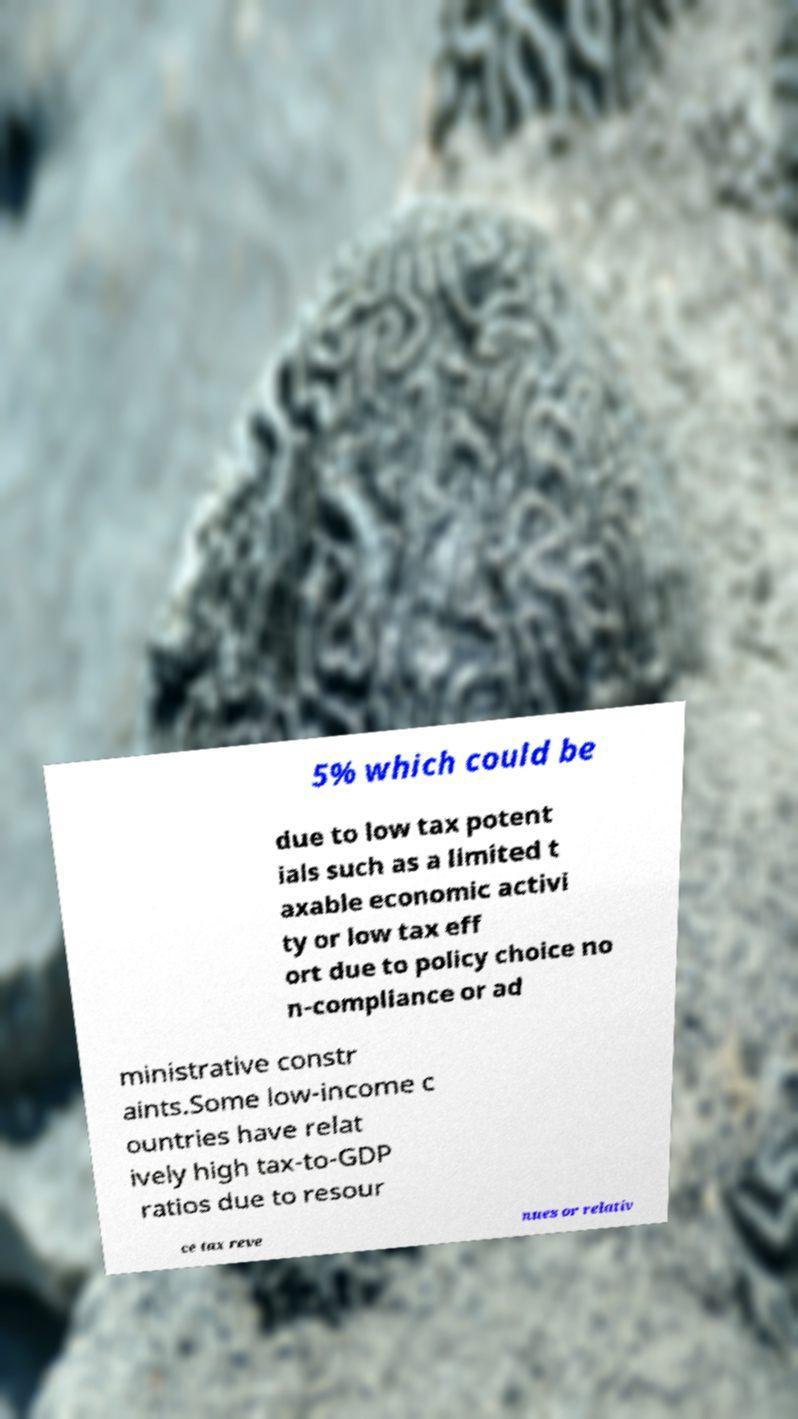There's text embedded in this image that I need extracted. Can you transcribe it verbatim? 5% which could be due to low tax potent ials such as a limited t axable economic activi ty or low tax eff ort due to policy choice no n-compliance or ad ministrative constr aints.Some low-income c ountries have relat ively high tax-to-GDP ratios due to resour ce tax reve nues or relativ 